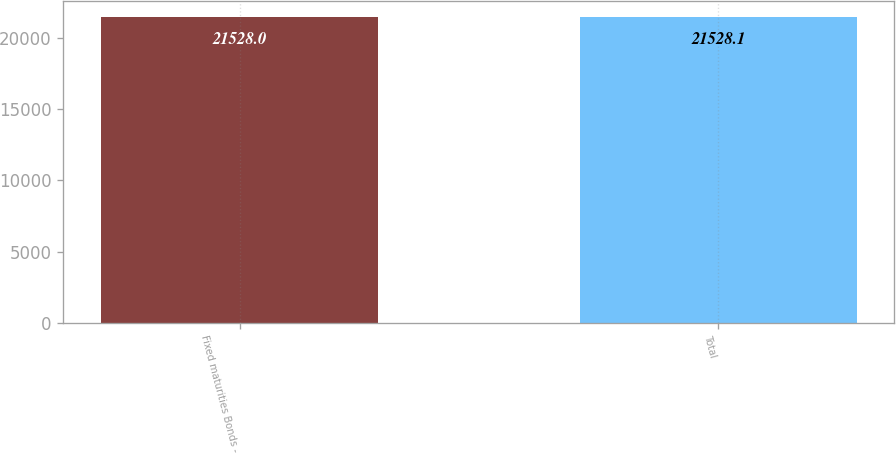<chart> <loc_0><loc_0><loc_500><loc_500><bar_chart><fcel>Fixed maturities Bonds -<fcel>Total<nl><fcel>21528<fcel>21528.1<nl></chart> 